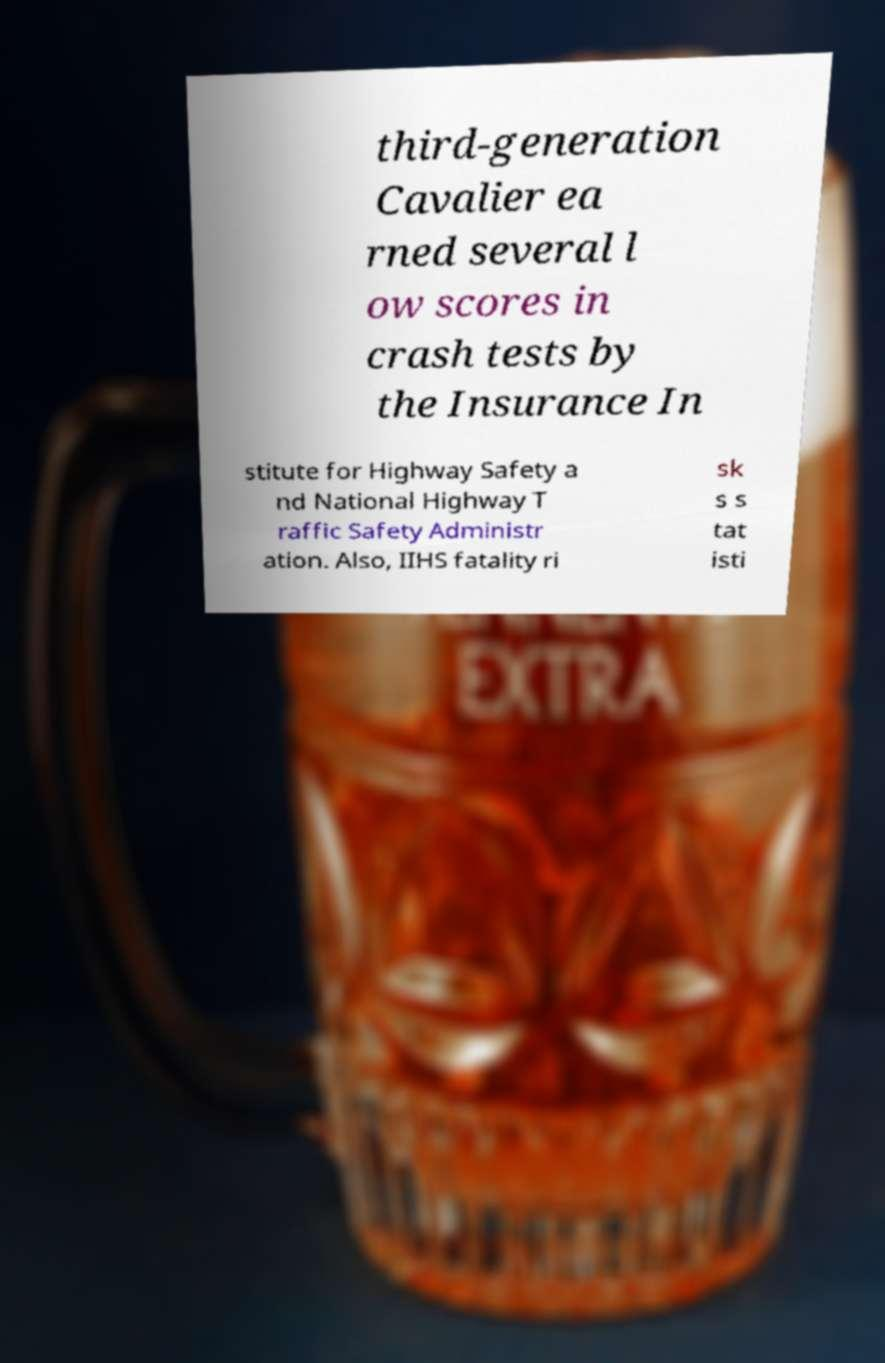Could you assist in decoding the text presented in this image and type it out clearly? third-generation Cavalier ea rned several l ow scores in crash tests by the Insurance In stitute for Highway Safety a nd National Highway T raffic Safety Administr ation. Also, IIHS fatality ri sk s s tat isti 